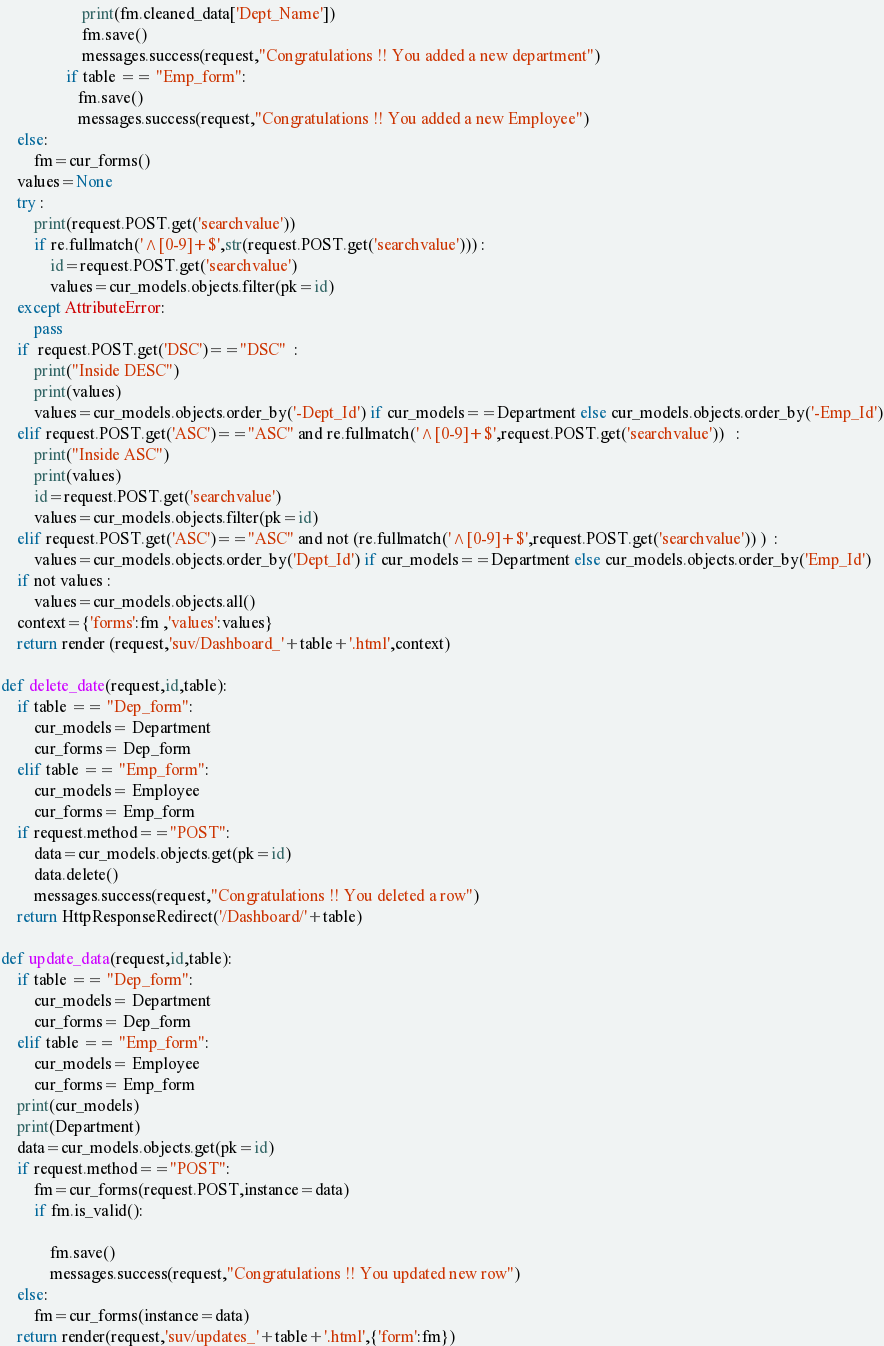<code> <loc_0><loc_0><loc_500><loc_500><_Python_>                    print(fm.cleaned_data['Dept_Name'])
                    fm.save()
                    messages.success(request,"Congratulations !! You added a new department")
                if table == "Emp_form":
                   fm.save()
                   messages.success(request,"Congratulations !! You added a new Employee")
    else:
        fm=cur_forms()
    values=None
    try :
        print(request.POST.get('searchvalue'))
        if re.fullmatch('^[0-9]+$',str(request.POST.get('searchvalue'))) :
            id=request.POST.get('searchvalue')
            values=cur_models.objects.filter(pk=id)
    except AttributeError:
        pass
    if  request.POST.get('DSC')=="DSC"  :
        print("Inside DESC")
        print(values)
        values=cur_models.objects.order_by('-Dept_Id') if cur_models==Department else cur_models.objects.order_by('-Emp_Id')
    elif request.POST.get('ASC')=="ASC" and re.fullmatch('^[0-9]+$',request.POST.get('searchvalue'))   :
        print("Inside ASC")
        print(values)
        id=request.POST.get('searchvalue')
        values=cur_models.objects.filter(pk=id)
    elif request.POST.get('ASC')=="ASC" and not (re.fullmatch('^[0-9]+$',request.POST.get('searchvalue')) )  :
        values=cur_models.objects.order_by('Dept_Id') if cur_models==Department else cur_models.objects.order_by('Emp_Id')
    if not values :
        values=cur_models.objects.all()
    context={'forms':fm ,'values':values}
    return render (request,'suv/Dashboard_'+table+'.html',context)

def delete_date(request,id,table):
    if table == "Dep_form":
        cur_models= Department
        cur_forms= Dep_form
    elif table == "Emp_form":
        cur_models= Employee
        cur_forms= Emp_form    
    if request.method=="POST":
        data=cur_models.objects.get(pk=id)
        data.delete()
        messages.success(request,"Congratulations !! You deleted a row")
    return HttpResponseRedirect('/Dashboard/'+table)

def update_data(request,id,table):
    if table == "Dep_form":
        cur_models= Department
        cur_forms= Dep_form
    elif table == "Emp_form":
        cur_models= Employee
        cur_forms= Emp_form   
    print(cur_models)
    print(Department)
    data=cur_models.objects.get(pk=id) 
    if request.method=="POST":
        fm=cur_forms(request.POST,instance=data)
        if fm.is_valid():
            
            fm.save()
            messages.success(request,"Congratulations !! You updated new row")
    else:
        fm=cur_forms(instance=data)
    return render(request,'suv/updates_'+table+'.html',{'form':fm})</code> 